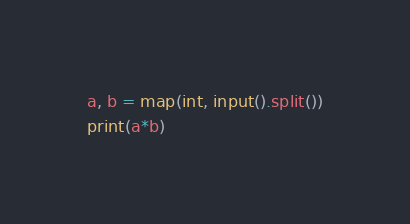<code> <loc_0><loc_0><loc_500><loc_500><_Python_>a, b = map(int, input().split())
print(a*b)</code> 